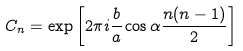Convert formula to latex. <formula><loc_0><loc_0><loc_500><loc_500>C _ { n } = \exp \left [ 2 \pi i \frac { b } { a } \cos \alpha \frac { n ( n - 1 ) } { 2 } \right ]</formula> 